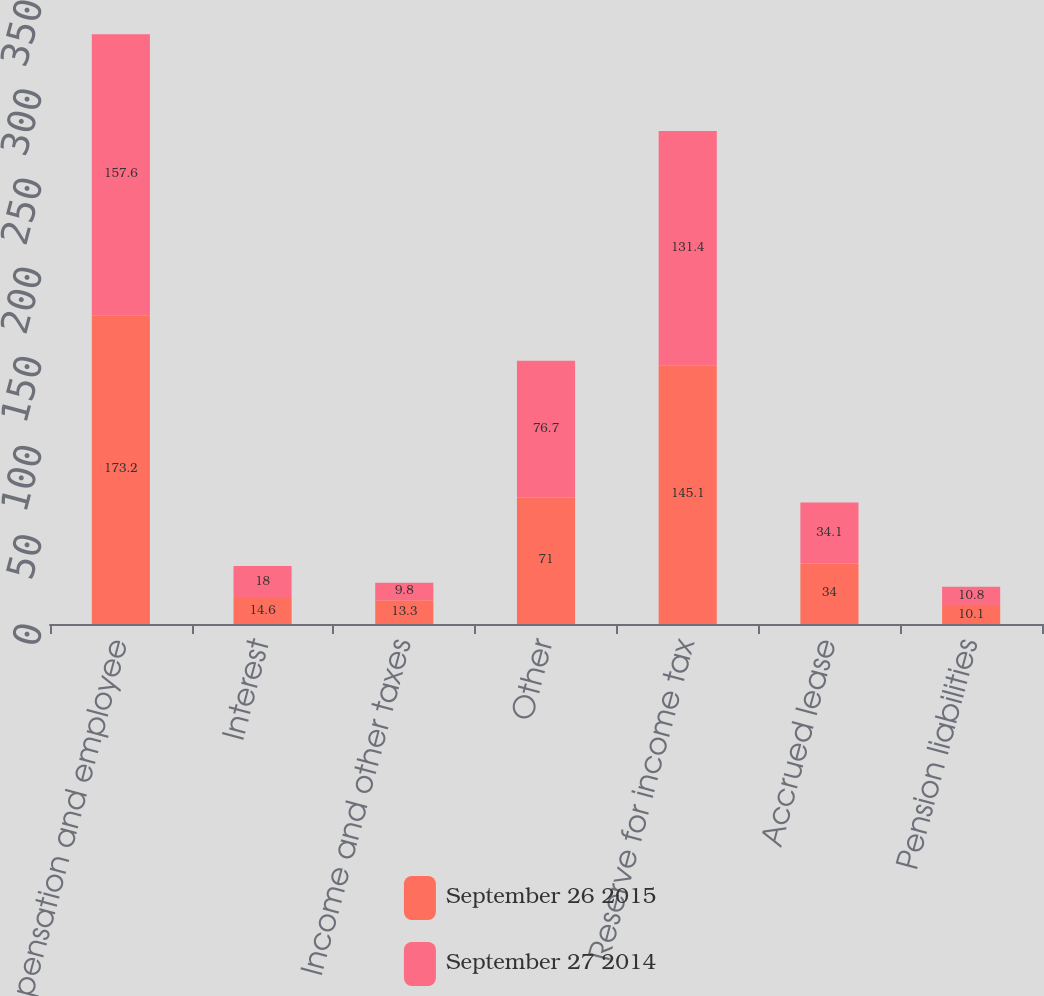Convert chart to OTSL. <chart><loc_0><loc_0><loc_500><loc_500><stacked_bar_chart><ecel><fcel>Compensation and employee<fcel>Interest<fcel>Income and other taxes<fcel>Other<fcel>Reserve for income tax<fcel>Accrued lease<fcel>Pension liabilities<nl><fcel>September 26 2015<fcel>173.2<fcel>14.6<fcel>13.3<fcel>71<fcel>145.1<fcel>34<fcel>10.1<nl><fcel>September 27 2014<fcel>157.6<fcel>18<fcel>9.8<fcel>76.7<fcel>131.4<fcel>34.1<fcel>10.8<nl></chart> 